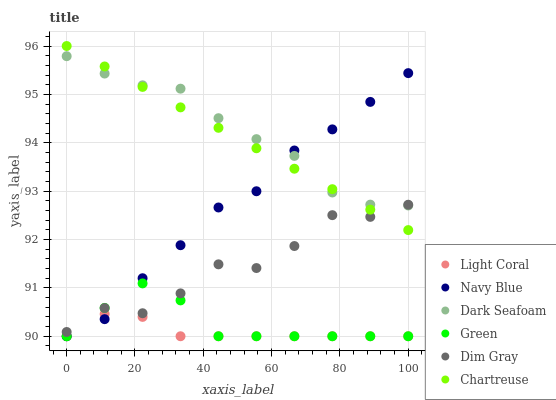Does Light Coral have the minimum area under the curve?
Answer yes or no. Yes. Does Dark Seafoam have the maximum area under the curve?
Answer yes or no. Yes. Does Navy Blue have the minimum area under the curve?
Answer yes or no. No. Does Navy Blue have the maximum area under the curve?
Answer yes or no. No. Is Chartreuse the smoothest?
Answer yes or no. Yes. Is Dim Gray the roughest?
Answer yes or no. Yes. Is Navy Blue the smoothest?
Answer yes or no. No. Is Navy Blue the roughest?
Answer yes or no. No. Does Navy Blue have the lowest value?
Answer yes or no. Yes. Does Chartreuse have the lowest value?
Answer yes or no. No. Does Chartreuse have the highest value?
Answer yes or no. Yes. Does Navy Blue have the highest value?
Answer yes or no. No. Is Green less than Chartreuse?
Answer yes or no. Yes. Is Dim Gray greater than Light Coral?
Answer yes or no. Yes. Does Chartreuse intersect Dark Seafoam?
Answer yes or no. Yes. Is Chartreuse less than Dark Seafoam?
Answer yes or no. No. Is Chartreuse greater than Dark Seafoam?
Answer yes or no. No. Does Green intersect Chartreuse?
Answer yes or no. No. 